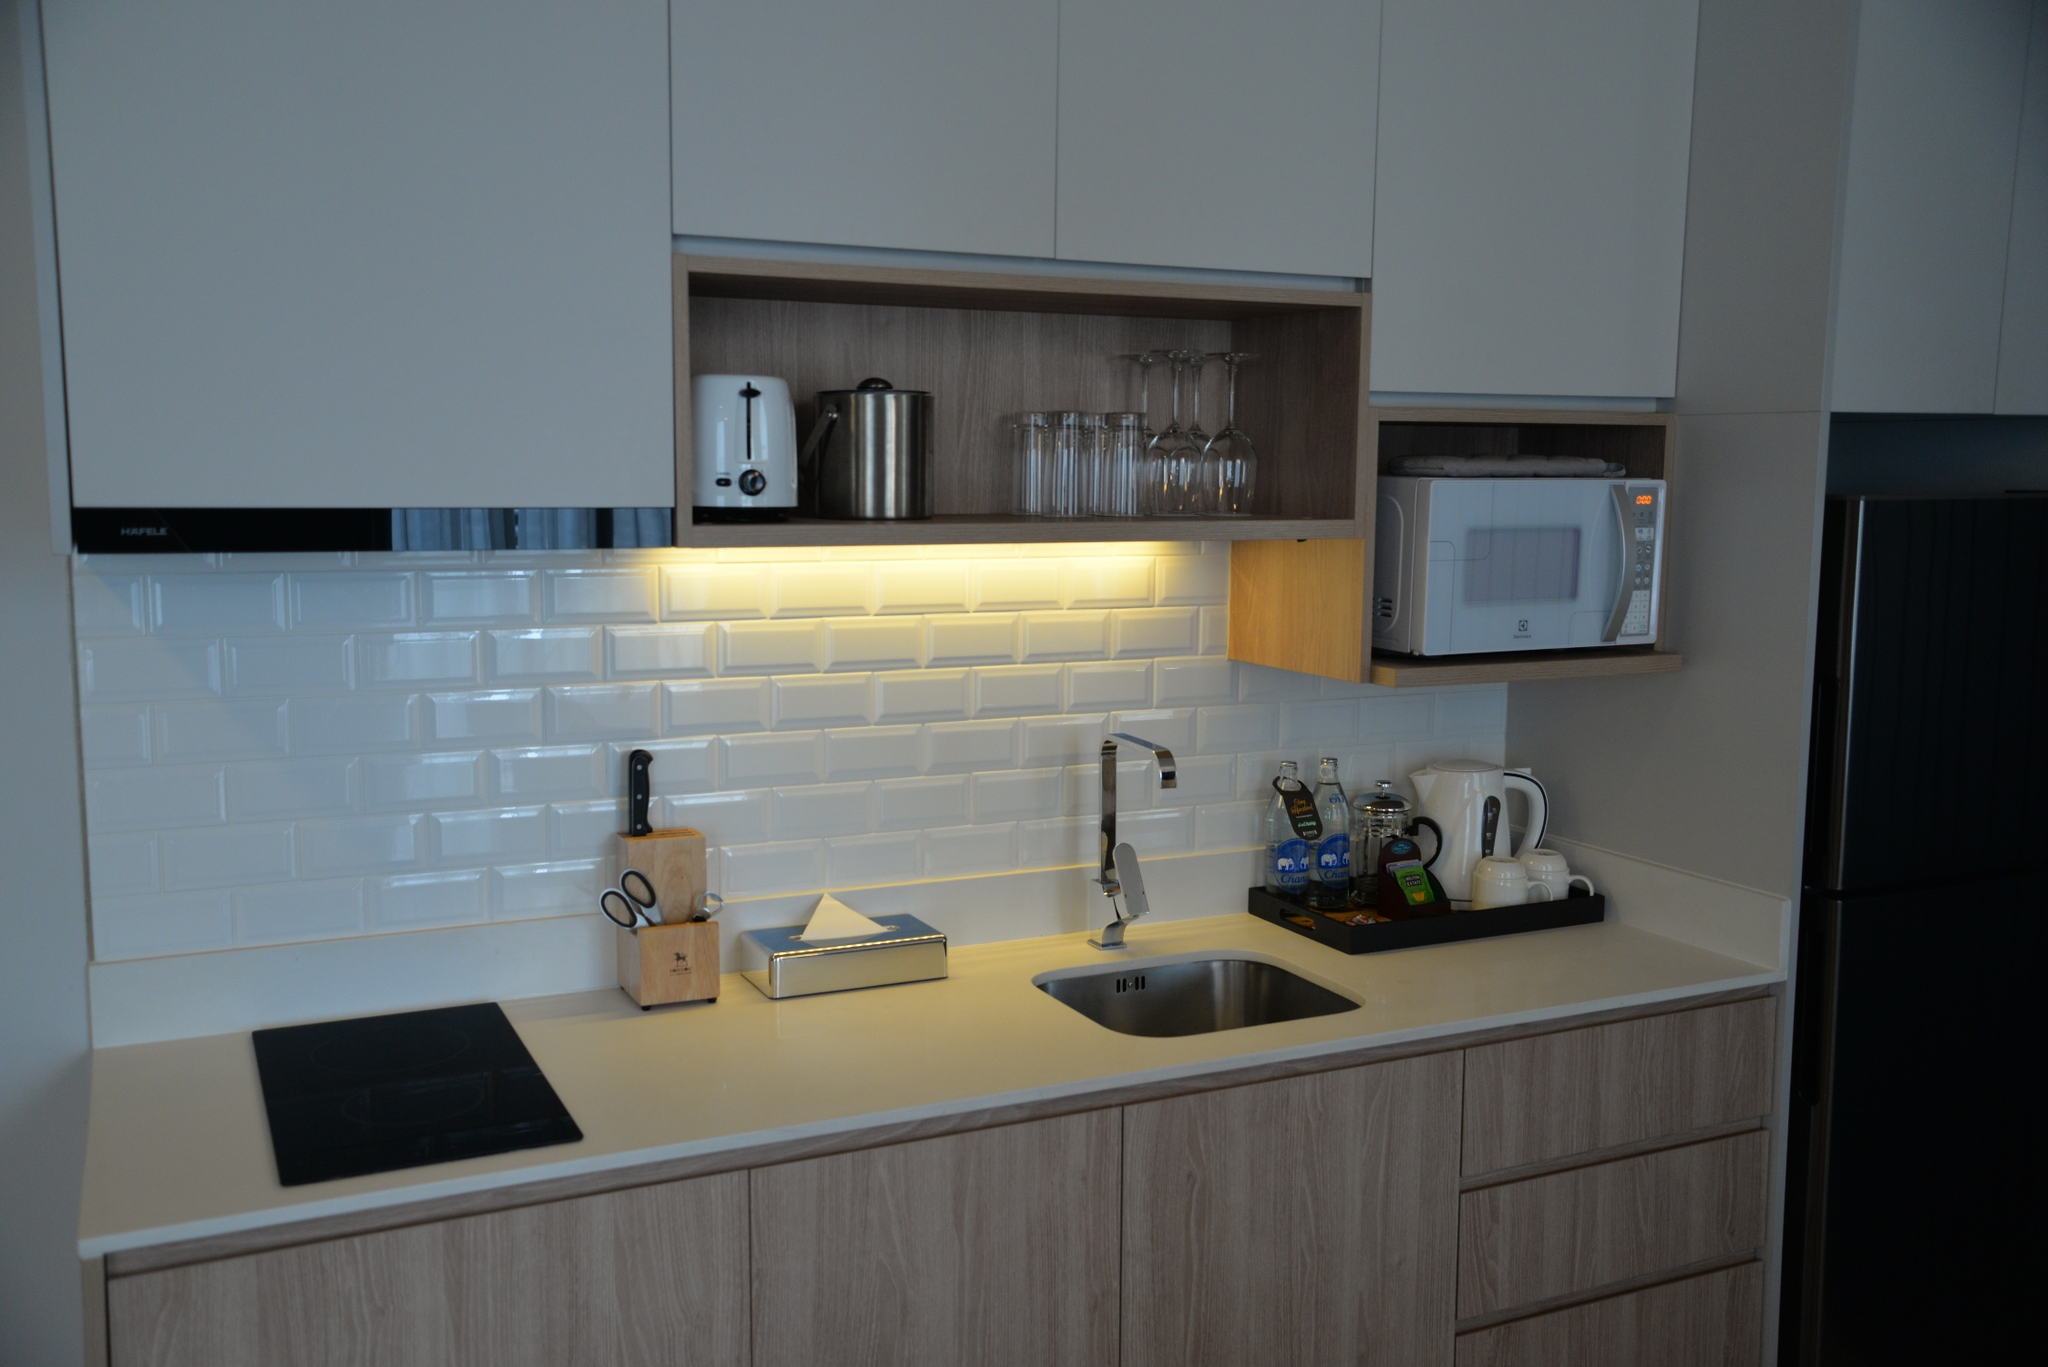Imagine this kitchen transforming into a futuristic cooking control center. What additional features would it have? In a futuristic transformation, this kitchen could become a high-tech cooking control center. Imagine a holographic interface incorporated within the backsplash tiles, allowing you to search recipes, stream cooking videos, and control appliances with the wave of a hand. The countertop could feature embedded scales and sensors that automatically track the ingredients' weight and nutritional information, syncing with your smart devices. The induction cooktop could be upgraded with smart, touch-sensitive zones that adjust heat based on the cookware used. Cabinets could be fitted with robotic arms that fetch and open pantry items, and the refrigerator could have a transparent touch screen, showing its contents and suggesting recipes based on what's inside. Above the sink, the window could double as an interactive screen displaying real-time weather updates, news, or even video calls. To top it all off, voice-controlled assistants would manage lighting, music, and even suggest wine pairings for your meal. 